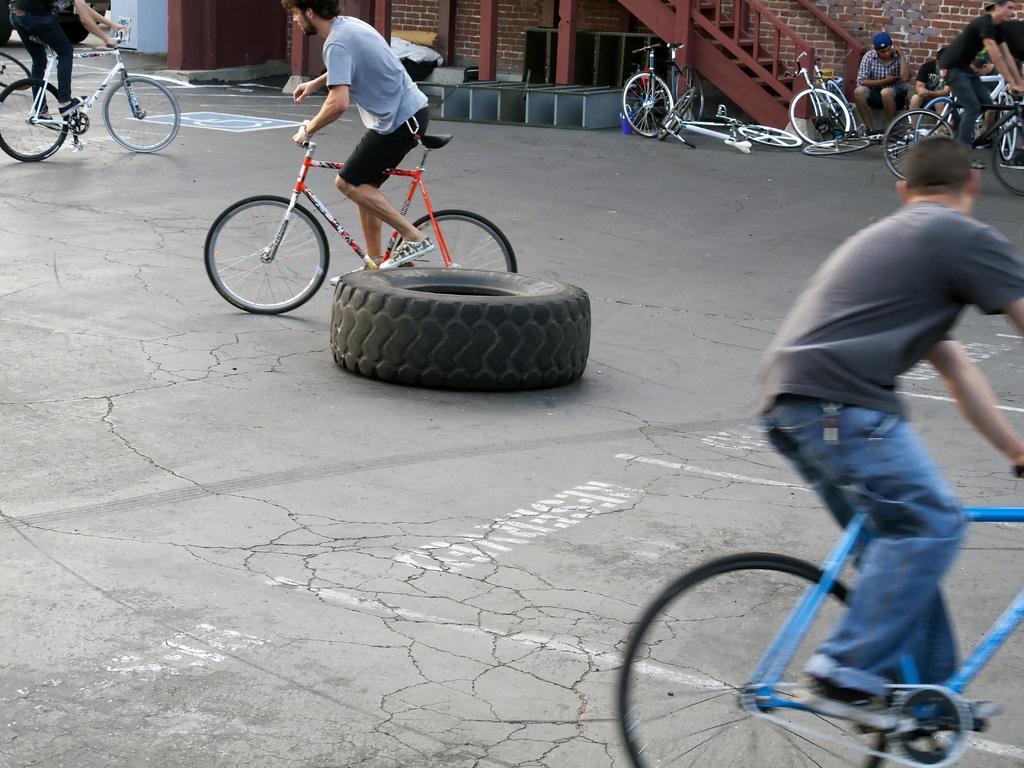Could you give a brief overview of what you see in this image? In this image there are some people who are sitting on a cycle and riding, and in the background there are some cycles and some persons are sitting and there is a staircase, wall and some windows. At the bottom there is floor and in the center there is one tyre. 